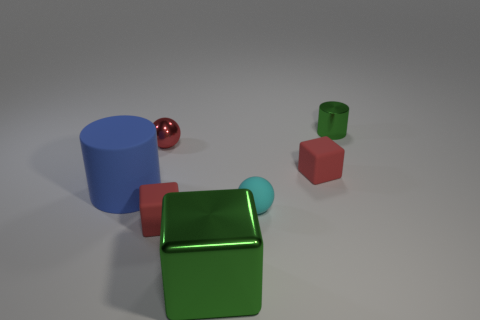Subtract 1 blocks. How many blocks are left? 2 Subtract all brown cylinders. How many red blocks are left? 2 Subtract all small rubber cubes. How many cubes are left? 1 Add 1 big purple cylinders. How many objects exist? 8 Subtract all cubes. How many objects are left? 4 Add 4 tiny red rubber cubes. How many tiny red rubber cubes exist? 6 Subtract 1 cyan spheres. How many objects are left? 6 Subtract all tiny green things. Subtract all metallic spheres. How many objects are left? 5 Add 7 red matte things. How many red matte things are left? 9 